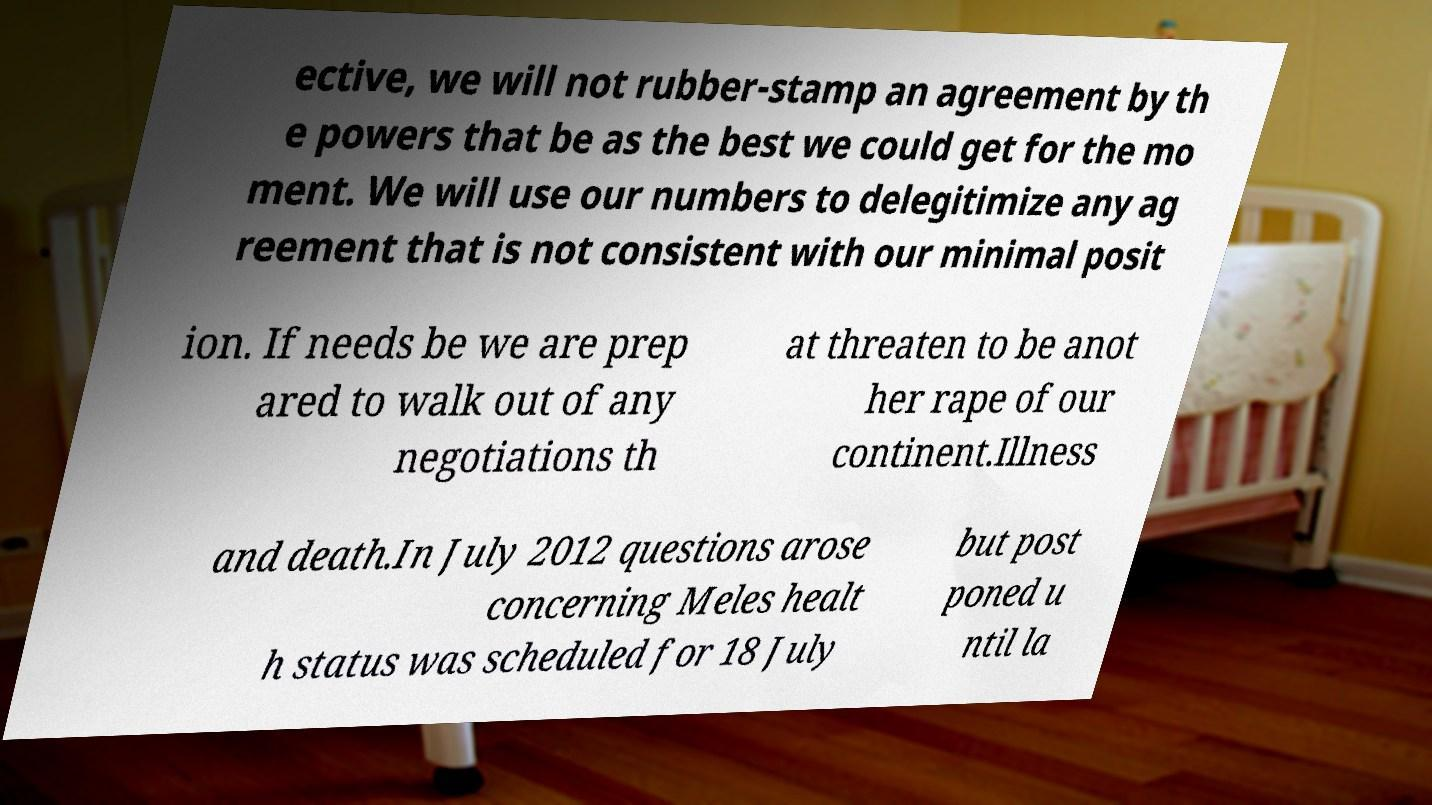Could you assist in decoding the text presented in this image and type it out clearly? ective, we will not rubber-stamp an agreement by th e powers that be as the best we could get for the mo ment. We will use our numbers to delegitimize any ag reement that is not consistent with our minimal posit ion. If needs be we are prep ared to walk out of any negotiations th at threaten to be anot her rape of our continent.Illness and death.In July 2012 questions arose concerning Meles healt h status was scheduled for 18 July but post poned u ntil la 